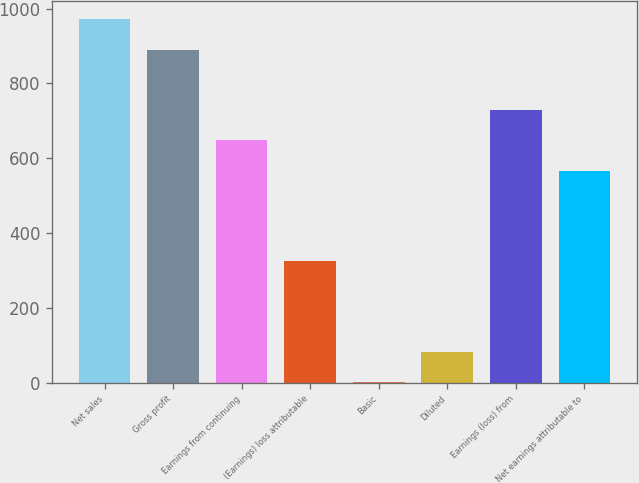Convert chart. <chart><loc_0><loc_0><loc_500><loc_500><bar_chart><fcel>Net sales<fcel>Gross profit<fcel>Earnings from continuing<fcel>(Earnings) loss attributable<fcel>Basic<fcel>Diluted<fcel>Earnings (loss) from<fcel>Net earnings attributable to<nl><fcel>971.86<fcel>890.9<fcel>648.02<fcel>324.18<fcel>0.34<fcel>81.3<fcel>728.98<fcel>567.06<nl></chart> 